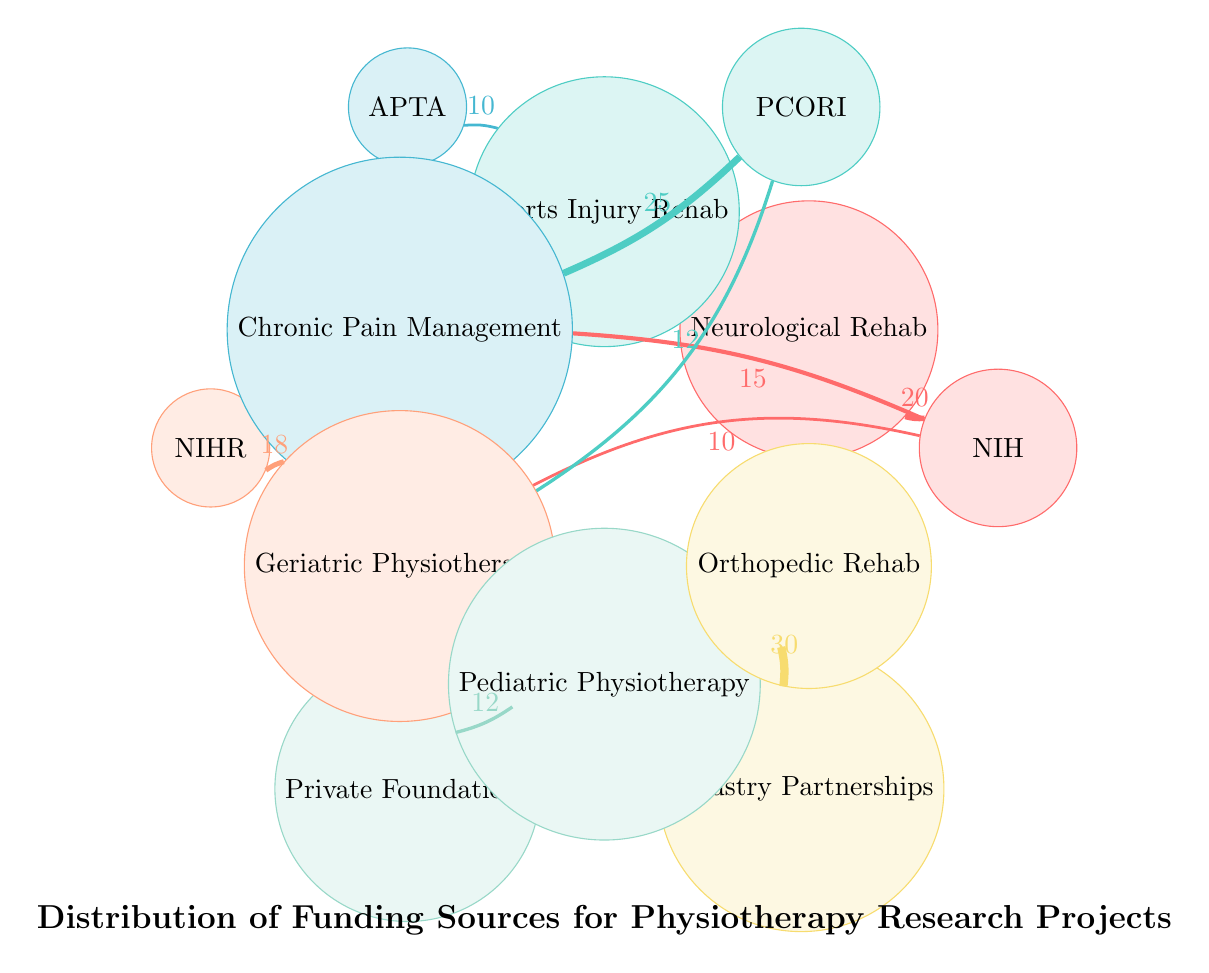What is the total number of funding sources depicted in the diagram? The diagram lists six funding sources: National Institutes of Health, Patient-Centered Outcomes Research Institute, American Physical Therapy Association, National Institute for Health and Care Research, Private Foundations, and Industry Partnerships. Counting these gives a total of six.
Answer: 6 Which research area receives the highest funding from industry partnerships? The diagram indicates that the line connecting Industry Partnerships and Orthopedic Rehabilitation has the highest value, which is 30, indicating that this research area receives the highest funding from industry partnerships.
Answer: Orthopedic Rehabilitation How much funding does the Patient-Centered Outcomes Research Institute allocate to Chronic Pain Management? The connection from Patient-Centered Outcomes Research Institute to Chronic Pain Management is labeled with the value 25, indicating this is the funding amount directed towards this specific research area.
Answer: 25 What is the combined funding value for Geriatric Physiotherapy from the National Institutes of Health and the Patient-Centered Outcomes Research Institute? The National Institutes of Health provides 10 and the Patient-Centered Outcomes Research Institute provides 12 for Geriatric Physiotherapy. Adding these two amounts together gives 10 + 12 = 22.
Answer: 22 Which funding source has allocated funds towards the most diverse research areas? By analyzing the connections, the National Institutes of Health funds Neurological Rehabilitation (20), Chronic Pain Management (15), and Geriatric Physiotherapy (10), totaling three research areas, which is more than any other funding source. Therefore, the National Institutes of Health has the widest range of funding allocation across research areas.
Answer: National Institutes of Health What is the funding amount for Pediatric Physiotherapy from Private Foundations? The line connecting Private Foundations to Pediatric Physiotherapy is labeled with the value 12, directly indicating the amount allocated to this area.
Answer: 12 How many connections are made from the American Physical Therapy Association? There is only one connection made from the American Physical Therapy Association indicating funding towards Sports Injury Rehabilitation with a value of 10. Therefore, it contributes just one connection on the diagram.
Answer: 1 Which research area has the least amount of funding from National Institutes of Health? From the National Institutes of Health, the funding amounts are 20 for Neurological Rehabilitation, 15 for Chronic Pain Management, 10 for Geriatric Physiotherapy. The lowest amount is 10, which corresponds to Geriatric Physiotherapy.
Answer: Geriatric Physiotherapy 